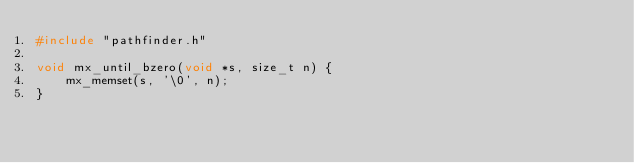Convert code to text. <code><loc_0><loc_0><loc_500><loc_500><_C_>#include "pathfinder.h"

void mx_until_bzero(void *s, size_t n) {
    mx_memset(s, '\0', n);
}
</code> 